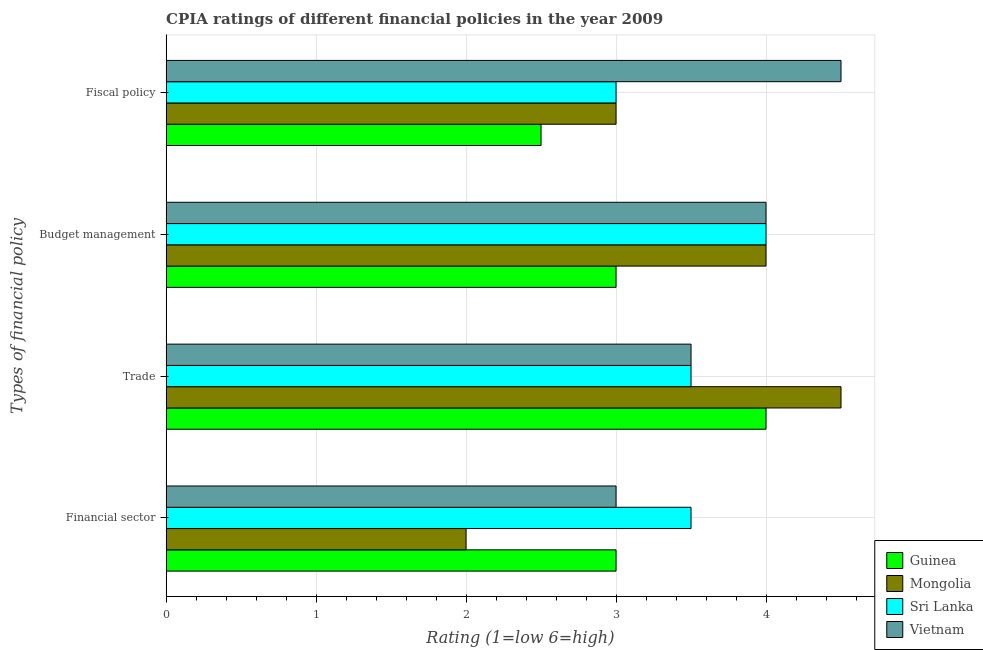Are the number of bars on each tick of the Y-axis equal?
Your answer should be very brief. Yes. How many bars are there on the 1st tick from the top?
Offer a terse response. 4. How many bars are there on the 4th tick from the bottom?
Offer a very short reply. 4. What is the label of the 3rd group of bars from the top?
Provide a succinct answer. Trade. Across all countries, what is the minimum cpia rating of fiscal policy?
Make the answer very short. 2.5. In which country was the cpia rating of financial sector maximum?
Offer a very short reply. Sri Lanka. In which country was the cpia rating of financial sector minimum?
Provide a short and direct response. Mongolia. What is the difference between the cpia rating of trade in Mongolia and the cpia rating of fiscal policy in Guinea?
Offer a terse response. 2. What is the average cpia rating of trade per country?
Keep it short and to the point. 3.88. What is the difference between the cpia rating of budget management and cpia rating of fiscal policy in Vietnam?
Your answer should be compact. -0.5. In how many countries, is the cpia rating of financial sector greater than the average cpia rating of financial sector taken over all countries?
Make the answer very short. 3. Is the sum of the cpia rating of fiscal policy in Sri Lanka and Mongolia greater than the maximum cpia rating of financial sector across all countries?
Give a very brief answer. Yes. What does the 2nd bar from the top in Budget management represents?
Ensure brevity in your answer.  Sri Lanka. What does the 2nd bar from the bottom in Budget management represents?
Offer a very short reply. Mongolia. How many bars are there?
Provide a succinct answer. 16. Are all the bars in the graph horizontal?
Offer a terse response. Yes. How many countries are there in the graph?
Your response must be concise. 4. What is the difference between two consecutive major ticks on the X-axis?
Your response must be concise. 1. Does the graph contain any zero values?
Make the answer very short. No. Does the graph contain grids?
Offer a terse response. Yes. How are the legend labels stacked?
Make the answer very short. Vertical. What is the title of the graph?
Your response must be concise. CPIA ratings of different financial policies in the year 2009. What is the label or title of the Y-axis?
Provide a short and direct response. Types of financial policy. What is the Rating (1=low 6=high) in Sri Lanka in Financial sector?
Provide a succinct answer. 3.5. What is the Rating (1=low 6=high) of Vietnam in Financial sector?
Provide a short and direct response. 3. What is the Rating (1=low 6=high) of Vietnam in Trade?
Your answer should be compact. 3.5. What is the Rating (1=low 6=high) of Mongolia in Budget management?
Your answer should be very brief. 4. What is the Rating (1=low 6=high) in Sri Lanka in Budget management?
Ensure brevity in your answer.  4. What is the Rating (1=low 6=high) of Vietnam in Budget management?
Keep it short and to the point. 4. What is the Rating (1=low 6=high) in Mongolia in Fiscal policy?
Offer a very short reply. 3. Across all Types of financial policy, what is the maximum Rating (1=low 6=high) of Guinea?
Make the answer very short. 4. Across all Types of financial policy, what is the maximum Rating (1=low 6=high) in Mongolia?
Your answer should be compact. 4.5. Across all Types of financial policy, what is the minimum Rating (1=low 6=high) in Mongolia?
Provide a succinct answer. 2. Across all Types of financial policy, what is the minimum Rating (1=low 6=high) in Sri Lanka?
Offer a terse response. 3. Across all Types of financial policy, what is the minimum Rating (1=low 6=high) of Vietnam?
Your response must be concise. 3. What is the total Rating (1=low 6=high) of Sri Lanka in the graph?
Your answer should be compact. 14. What is the total Rating (1=low 6=high) of Vietnam in the graph?
Your response must be concise. 15. What is the difference between the Rating (1=low 6=high) in Guinea in Financial sector and that in Trade?
Offer a very short reply. -1. What is the difference between the Rating (1=low 6=high) of Mongolia in Financial sector and that in Trade?
Your answer should be compact. -2.5. What is the difference between the Rating (1=low 6=high) of Sri Lanka in Financial sector and that in Trade?
Provide a succinct answer. 0. What is the difference between the Rating (1=low 6=high) in Vietnam in Financial sector and that in Trade?
Your response must be concise. -0.5. What is the difference between the Rating (1=low 6=high) of Guinea in Financial sector and that in Budget management?
Offer a terse response. 0. What is the difference between the Rating (1=low 6=high) of Mongolia in Financial sector and that in Budget management?
Ensure brevity in your answer.  -2. What is the difference between the Rating (1=low 6=high) in Sri Lanka in Financial sector and that in Budget management?
Provide a short and direct response. -0.5. What is the difference between the Rating (1=low 6=high) of Sri Lanka in Financial sector and that in Fiscal policy?
Give a very brief answer. 0.5. What is the difference between the Rating (1=low 6=high) in Vietnam in Financial sector and that in Fiscal policy?
Keep it short and to the point. -1.5. What is the difference between the Rating (1=low 6=high) of Guinea in Trade and that in Budget management?
Your answer should be compact. 1. What is the difference between the Rating (1=low 6=high) of Mongolia in Trade and that in Budget management?
Offer a terse response. 0.5. What is the difference between the Rating (1=low 6=high) in Sri Lanka in Trade and that in Budget management?
Offer a very short reply. -0.5. What is the difference between the Rating (1=low 6=high) of Vietnam in Trade and that in Budget management?
Your answer should be compact. -0.5. What is the difference between the Rating (1=low 6=high) in Guinea in Trade and that in Fiscal policy?
Make the answer very short. 1.5. What is the difference between the Rating (1=low 6=high) in Sri Lanka in Trade and that in Fiscal policy?
Keep it short and to the point. 0.5. What is the difference between the Rating (1=low 6=high) in Guinea in Budget management and that in Fiscal policy?
Provide a short and direct response. 0.5. What is the difference between the Rating (1=low 6=high) of Mongolia in Budget management and that in Fiscal policy?
Your answer should be very brief. 1. What is the difference between the Rating (1=low 6=high) in Sri Lanka in Budget management and that in Fiscal policy?
Your answer should be compact. 1. What is the difference between the Rating (1=low 6=high) of Guinea in Financial sector and the Rating (1=low 6=high) of Mongolia in Trade?
Your answer should be very brief. -1.5. What is the difference between the Rating (1=low 6=high) of Guinea in Financial sector and the Rating (1=low 6=high) of Sri Lanka in Trade?
Offer a terse response. -0.5. What is the difference between the Rating (1=low 6=high) of Mongolia in Financial sector and the Rating (1=low 6=high) of Sri Lanka in Trade?
Offer a terse response. -1.5. What is the difference between the Rating (1=low 6=high) of Sri Lanka in Financial sector and the Rating (1=low 6=high) of Vietnam in Trade?
Provide a short and direct response. 0. What is the difference between the Rating (1=low 6=high) of Guinea in Financial sector and the Rating (1=low 6=high) of Sri Lanka in Budget management?
Give a very brief answer. -1. What is the difference between the Rating (1=low 6=high) of Sri Lanka in Financial sector and the Rating (1=low 6=high) of Vietnam in Budget management?
Keep it short and to the point. -0.5. What is the difference between the Rating (1=low 6=high) in Guinea in Financial sector and the Rating (1=low 6=high) in Sri Lanka in Fiscal policy?
Offer a terse response. 0. What is the difference between the Rating (1=low 6=high) in Mongolia in Financial sector and the Rating (1=low 6=high) in Sri Lanka in Fiscal policy?
Your answer should be compact. -1. What is the difference between the Rating (1=low 6=high) in Mongolia in Financial sector and the Rating (1=low 6=high) in Vietnam in Fiscal policy?
Make the answer very short. -2.5. What is the difference between the Rating (1=low 6=high) in Sri Lanka in Financial sector and the Rating (1=low 6=high) in Vietnam in Fiscal policy?
Provide a succinct answer. -1. What is the difference between the Rating (1=low 6=high) of Mongolia in Trade and the Rating (1=low 6=high) of Sri Lanka in Budget management?
Offer a terse response. 0.5. What is the difference between the Rating (1=low 6=high) in Mongolia in Trade and the Rating (1=low 6=high) in Vietnam in Budget management?
Your response must be concise. 0.5. What is the difference between the Rating (1=low 6=high) in Guinea in Trade and the Rating (1=low 6=high) in Mongolia in Fiscal policy?
Provide a succinct answer. 1. What is the difference between the Rating (1=low 6=high) in Guinea in Trade and the Rating (1=low 6=high) in Sri Lanka in Fiscal policy?
Ensure brevity in your answer.  1. What is the difference between the Rating (1=low 6=high) of Guinea in Trade and the Rating (1=low 6=high) of Vietnam in Fiscal policy?
Offer a very short reply. -0.5. What is the difference between the Rating (1=low 6=high) of Mongolia in Trade and the Rating (1=low 6=high) of Sri Lanka in Fiscal policy?
Your answer should be compact. 1.5. What is the difference between the Rating (1=low 6=high) of Sri Lanka in Trade and the Rating (1=low 6=high) of Vietnam in Fiscal policy?
Your answer should be compact. -1. What is the difference between the Rating (1=low 6=high) in Guinea in Budget management and the Rating (1=low 6=high) in Vietnam in Fiscal policy?
Give a very brief answer. -1.5. What is the difference between the Rating (1=low 6=high) in Mongolia in Budget management and the Rating (1=low 6=high) in Sri Lanka in Fiscal policy?
Your answer should be compact. 1. What is the difference between the Rating (1=low 6=high) in Mongolia in Budget management and the Rating (1=low 6=high) in Vietnam in Fiscal policy?
Give a very brief answer. -0.5. What is the difference between the Rating (1=low 6=high) of Sri Lanka in Budget management and the Rating (1=low 6=high) of Vietnam in Fiscal policy?
Give a very brief answer. -0.5. What is the average Rating (1=low 6=high) of Guinea per Types of financial policy?
Provide a short and direct response. 3.12. What is the average Rating (1=low 6=high) in Mongolia per Types of financial policy?
Offer a very short reply. 3.38. What is the average Rating (1=low 6=high) of Vietnam per Types of financial policy?
Give a very brief answer. 3.75. What is the difference between the Rating (1=low 6=high) of Guinea and Rating (1=low 6=high) of Vietnam in Financial sector?
Give a very brief answer. 0. What is the difference between the Rating (1=low 6=high) in Sri Lanka and Rating (1=low 6=high) in Vietnam in Financial sector?
Make the answer very short. 0.5. What is the difference between the Rating (1=low 6=high) in Guinea and Rating (1=low 6=high) in Sri Lanka in Trade?
Your response must be concise. 0.5. What is the difference between the Rating (1=low 6=high) of Guinea and Rating (1=low 6=high) of Vietnam in Trade?
Your response must be concise. 0.5. What is the difference between the Rating (1=low 6=high) of Mongolia and Rating (1=low 6=high) of Vietnam in Trade?
Keep it short and to the point. 1. What is the difference between the Rating (1=low 6=high) of Sri Lanka and Rating (1=low 6=high) of Vietnam in Trade?
Make the answer very short. 0. What is the difference between the Rating (1=low 6=high) in Guinea and Rating (1=low 6=high) in Mongolia in Budget management?
Keep it short and to the point. -1. What is the difference between the Rating (1=low 6=high) of Guinea and Rating (1=low 6=high) of Sri Lanka in Budget management?
Ensure brevity in your answer.  -1. What is the difference between the Rating (1=low 6=high) in Mongolia and Rating (1=low 6=high) in Sri Lanka in Budget management?
Offer a terse response. 0. What is the difference between the Rating (1=low 6=high) in Guinea and Rating (1=low 6=high) in Mongolia in Fiscal policy?
Offer a terse response. -0.5. What is the difference between the Rating (1=low 6=high) in Guinea and Rating (1=low 6=high) in Sri Lanka in Fiscal policy?
Provide a short and direct response. -0.5. What is the difference between the Rating (1=low 6=high) in Guinea and Rating (1=low 6=high) in Vietnam in Fiscal policy?
Keep it short and to the point. -2. What is the difference between the Rating (1=low 6=high) of Mongolia and Rating (1=low 6=high) of Vietnam in Fiscal policy?
Offer a terse response. -1.5. What is the difference between the Rating (1=low 6=high) in Sri Lanka and Rating (1=low 6=high) in Vietnam in Fiscal policy?
Keep it short and to the point. -1.5. What is the ratio of the Rating (1=low 6=high) of Guinea in Financial sector to that in Trade?
Offer a very short reply. 0.75. What is the ratio of the Rating (1=low 6=high) of Mongolia in Financial sector to that in Trade?
Your answer should be compact. 0.44. What is the ratio of the Rating (1=low 6=high) in Guinea in Financial sector to that in Budget management?
Your answer should be very brief. 1. What is the ratio of the Rating (1=low 6=high) of Sri Lanka in Financial sector to that in Budget management?
Offer a terse response. 0.88. What is the ratio of the Rating (1=low 6=high) of Vietnam in Financial sector to that in Budget management?
Make the answer very short. 0.75. What is the ratio of the Rating (1=low 6=high) in Vietnam in Financial sector to that in Fiscal policy?
Give a very brief answer. 0.67. What is the ratio of the Rating (1=low 6=high) in Mongolia in Trade to that in Budget management?
Provide a short and direct response. 1.12. What is the ratio of the Rating (1=low 6=high) in Guinea in Trade to that in Fiscal policy?
Your answer should be very brief. 1.6. What is the ratio of the Rating (1=low 6=high) in Mongolia in Trade to that in Fiscal policy?
Offer a terse response. 1.5. What is the ratio of the Rating (1=low 6=high) in Sri Lanka in Trade to that in Fiscal policy?
Keep it short and to the point. 1.17. What is the ratio of the Rating (1=low 6=high) in Vietnam in Trade to that in Fiscal policy?
Provide a short and direct response. 0.78. What is the difference between the highest and the second highest Rating (1=low 6=high) in Mongolia?
Your answer should be very brief. 0.5. What is the difference between the highest and the second highest Rating (1=low 6=high) in Sri Lanka?
Make the answer very short. 0.5. What is the difference between the highest and the lowest Rating (1=low 6=high) of Mongolia?
Your answer should be compact. 2.5. 